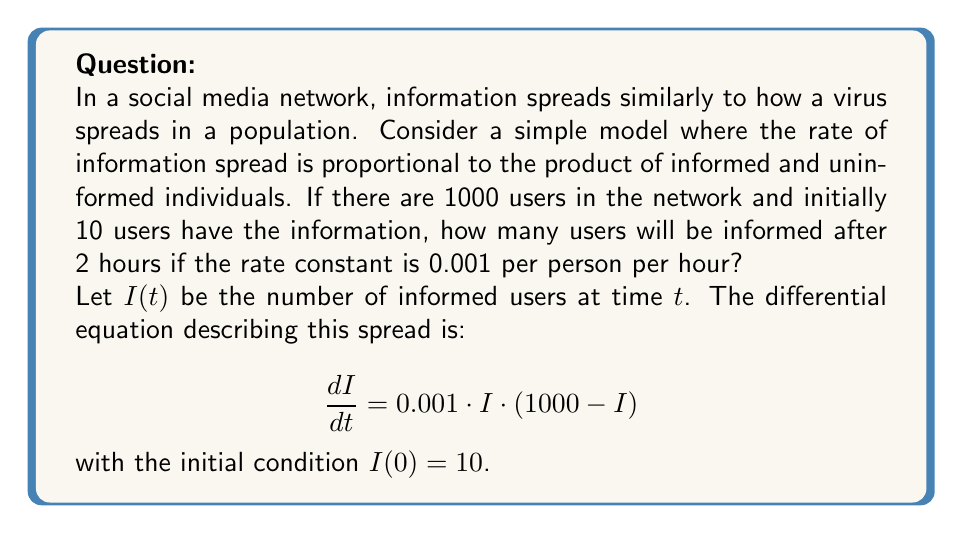Give your solution to this math problem. To solve this problem, we need to use the logistic growth model, which is a common epidemic model used in media studies to describe information spread.

1) The differential equation given is a separable equation. We can solve it as follows:

   $$\int \frac{dI}{I(1000-I)} = \int 0.001 dt$$

2) Using partial fraction decomposition:

   $$\frac{1}{1000} \left(\frac{1}{I} + \frac{1}{1000-I}\right) dI = 0.001 dt$$

3) Integrating both sides:

   $$\frac{1}{1000} [\ln|I| - \ln|1000-I|] = 0.001t + C$$

4) Using the initial condition $I(0) = 10$, we can find the value of $C$:

   $$\frac{1}{1000} [\ln(10) - \ln(990)] = C$$

5) Substituting this back into the equation:

   $$\frac{1}{1000} [\ln|I| - \ln|1000-I|] = 0.001t + \frac{1}{1000} [\ln(10) - \ln(990)]$$

6) Simplifying:

   $$\ln\left(\frac{I}{1000-I}\right) = t + \ln\left(\frac{10}{990}\right)$$

7) Taking the exponential of both sides:

   $$\frac{I}{1000-I} = \frac{10}{990} e^t$$

8) Solving for $I$:

   $$I = \frac{10000e^t}{990 + 10e^t}$$

9) Now, we need to find $I(2)$. Substituting $t=2$:

   $$I(2) = \frac{10000e^2}{990 + 10e^2} \approx 71.65$$

10) Rounding to the nearest whole number (as we can't have a fraction of a person):

    $I(2) \approx 72$
Answer: 72 users 